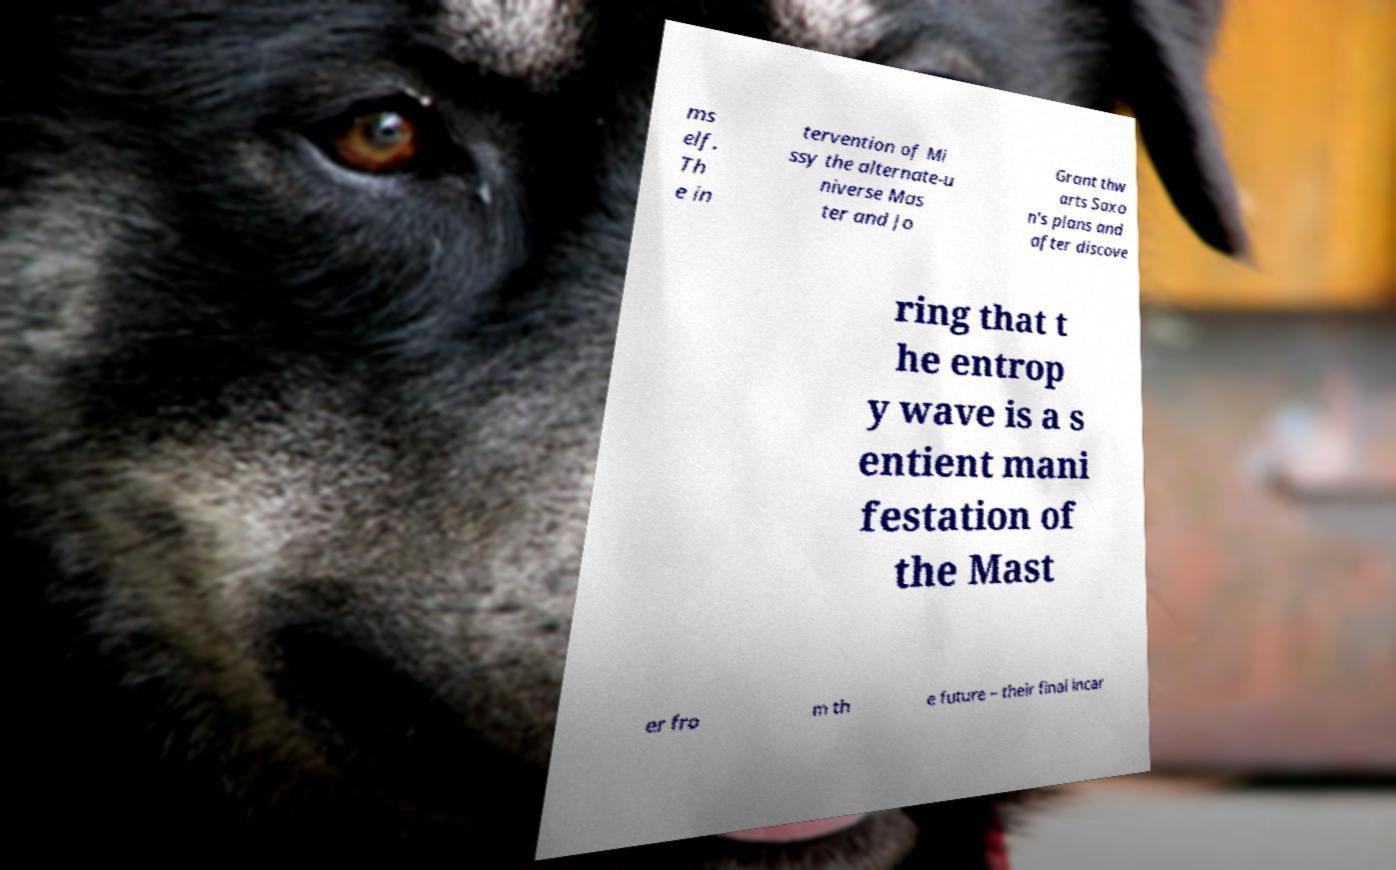Please identify and transcribe the text found in this image. ms elf. Th e in tervention of Mi ssy the alternate-u niverse Mas ter and Jo Grant thw arts Saxo n's plans and after discove ring that t he entrop y wave is a s entient mani festation of the Mast er fro m th e future – their final incar 